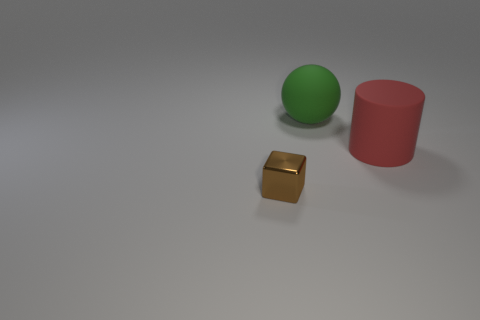Add 3 tiny purple cylinders. How many objects exist? 6 Subtract all balls. How many objects are left? 2 Subtract all big green matte cubes. Subtract all small objects. How many objects are left? 2 Add 1 large green matte objects. How many large green matte objects are left? 2 Add 3 large blue metal cylinders. How many large blue metal cylinders exist? 3 Subtract 1 brown blocks. How many objects are left? 2 